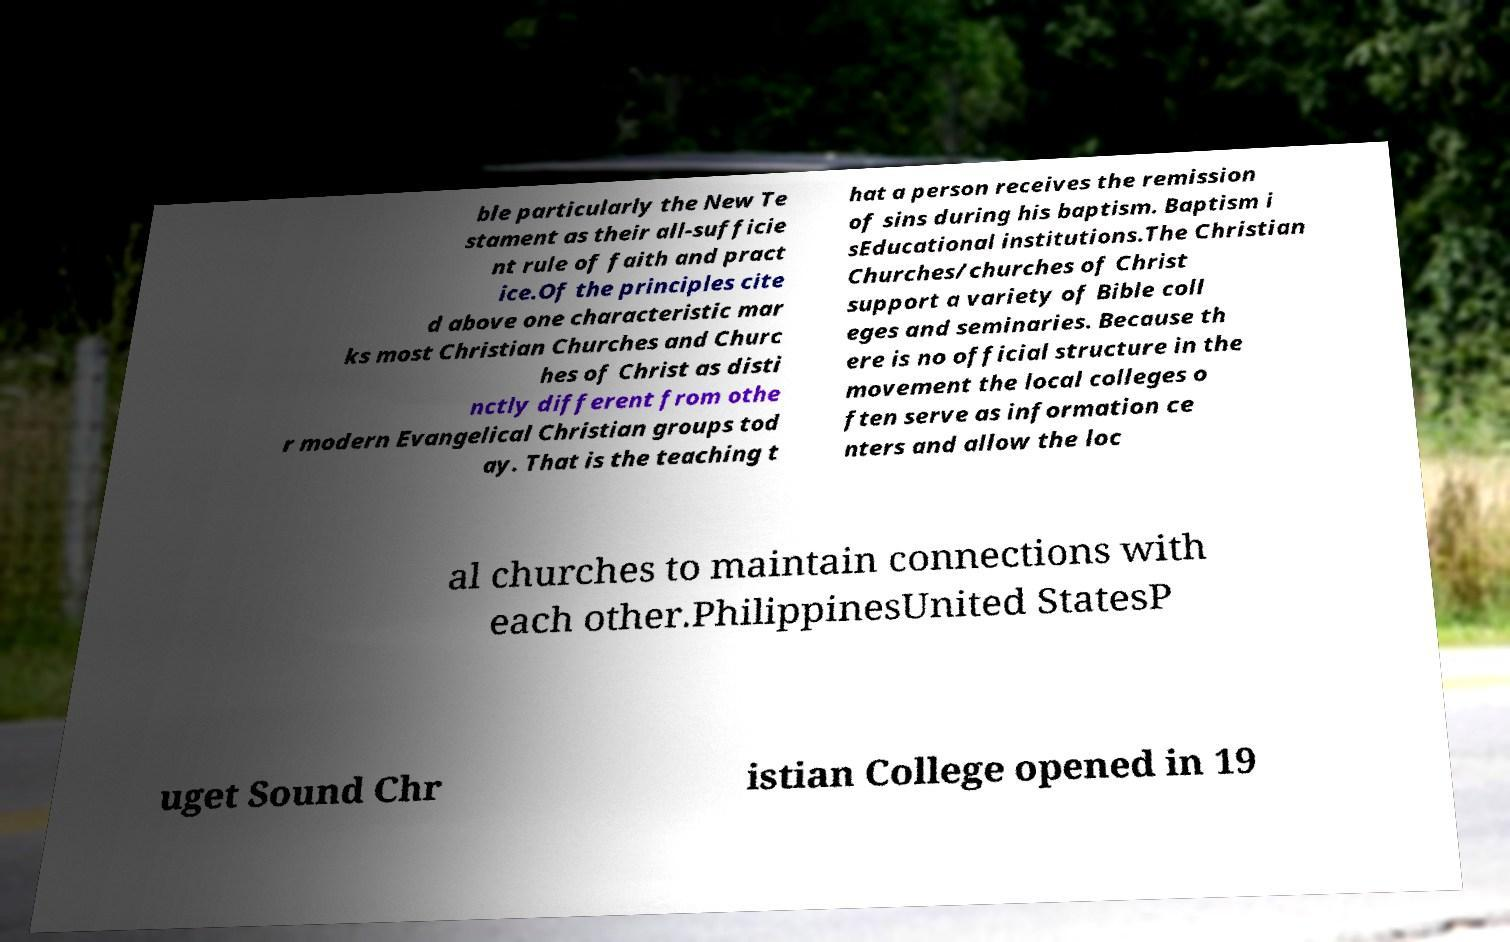There's text embedded in this image that I need extracted. Can you transcribe it verbatim? ble particularly the New Te stament as their all-sufficie nt rule of faith and pract ice.Of the principles cite d above one characteristic mar ks most Christian Churches and Churc hes of Christ as disti nctly different from othe r modern Evangelical Christian groups tod ay. That is the teaching t hat a person receives the remission of sins during his baptism. Baptism i sEducational institutions.The Christian Churches/churches of Christ support a variety of Bible coll eges and seminaries. Because th ere is no official structure in the movement the local colleges o ften serve as information ce nters and allow the loc al churches to maintain connections with each other.PhilippinesUnited StatesP uget Sound Chr istian College opened in 19 